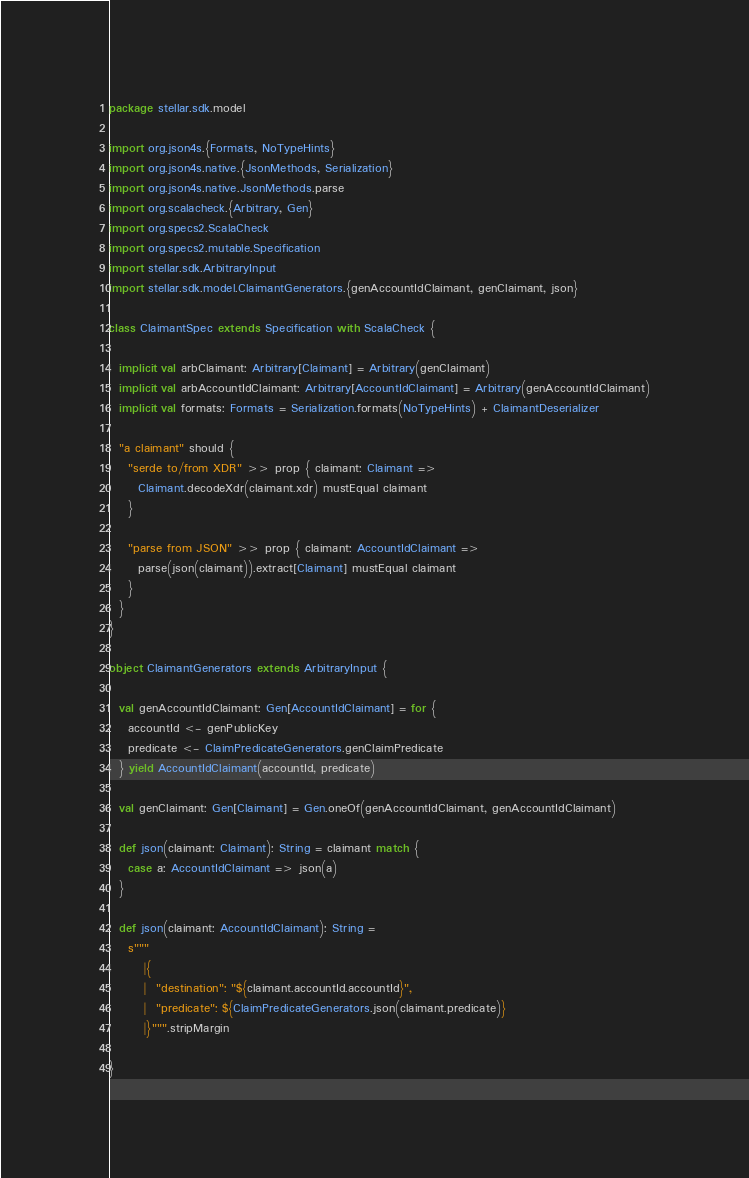Convert code to text. <code><loc_0><loc_0><loc_500><loc_500><_Scala_>package stellar.sdk.model

import org.json4s.{Formats, NoTypeHints}
import org.json4s.native.{JsonMethods, Serialization}
import org.json4s.native.JsonMethods.parse
import org.scalacheck.{Arbitrary, Gen}
import org.specs2.ScalaCheck
import org.specs2.mutable.Specification
import stellar.sdk.ArbitraryInput
import stellar.sdk.model.ClaimantGenerators.{genAccountIdClaimant, genClaimant, json}

class ClaimantSpec extends Specification with ScalaCheck {

  implicit val arbClaimant: Arbitrary[Claimant] = Arbitrary(genClaimant)
  implicit val arbAccountIdClaimant: Arbitrary[AccountIdClaimant] = Arbitrary(genAccountIdClaimant)
  implicit val formats: Formats = Serialization.formats(NoTypeHints) + ClaimantDeserializer

  "a claimant" should {
    "serde to/from XDR" >> prop { claimant: Claimant =>
      Claimant.decodeXdr(claimant.xdr) mustEqual claimant
    }

    "parse from JSON" >> prop { claimant: AccountIdClaimant =>
      parse(json(claimant)).extract[Claimant] mustEqual claimant
    }
  }
}

object ClaimantGenerators extends ArbitraryInput {

  val genAccountIdClaimant: Gen[AccountIdClaimant] = for {
    accountId <- genPublicKey
    predicate <- ClaimPredicateGenerators.genClaimPredicate
  } yield AccountIdClaimant(accountId, predicate)

  val genClaimant: Gen[Claimant] = Gen.oneOf(genAccountIdClaimant, genAccountIdClaimant)

  def json(claimant: Claimant): String = claimant match {
    case a: AccountIdClaimant => json(a)
  }

  def json(claimant: AccountIdClaimant): String =
    s"""
       |{
       |  "destination": "${claimant.accountId.accountId}",
       |  "predicate": ${ClaimPredicateGenerators.json(claimant.predicate)}
       |}""".stripMargin

}</code> 